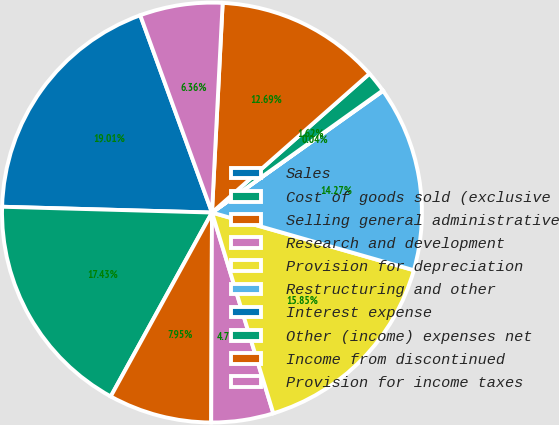Convert chart. <chart><loc_0><loc_0><loc_500><loc_500><pie_chart><fcel>Sales<fcel>Cost of goods sold (exclusive<fcel>Selling general administrative<fcel>Research and development<fcel>Provision for depreciation<fcel>Restructuring and other<fcel>Interest expense<fcel>Other (income) expenses net<fcel>Income from discontinued<fcel>Provision for income taxes<nl><fcel>19.01%<fcel>17.43%<fcel>7.95%<fcel>4.78%<fcel>15.85%<fcel>14.27%<fcel>0.04%<fcel>1.62%<fcel>12.69%<fcel>6.36%<nl></chart> 